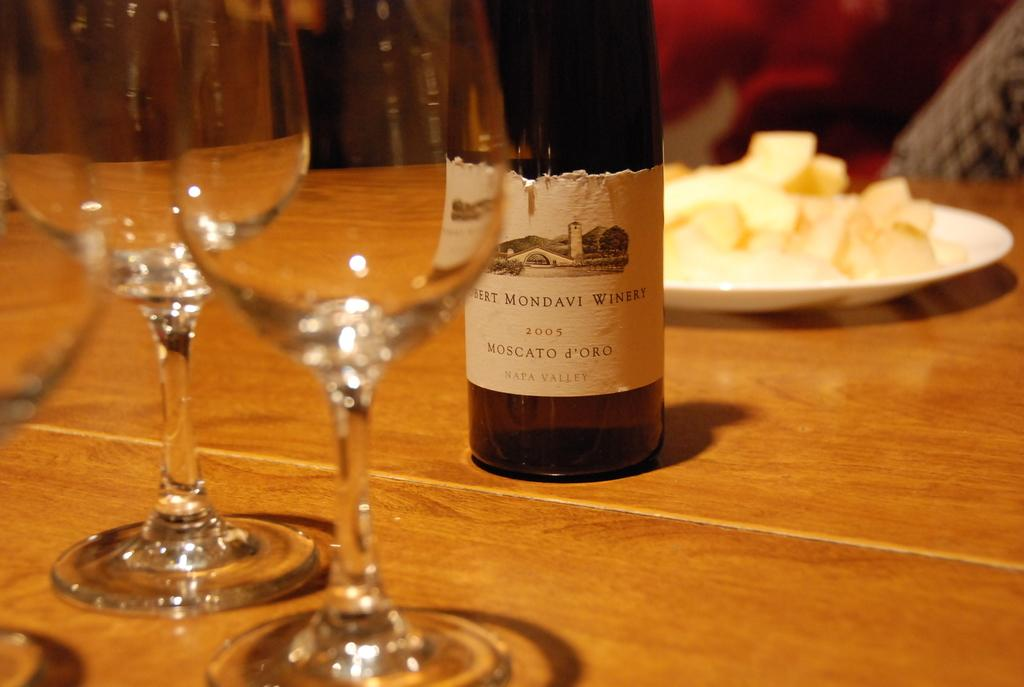What type of tableware can be seen in the image? There are glasses in the image. What else is present on the table in the image? There is a bottle and a plate of food on the table. What might be used for drinking in the image? The glasses in the image can be used for drinking. What is on the plate that is visible in the image? There is a plate of food in the image. What type of science experiment is being conducted on the table in the image? There is no science experiment present in the image; it features glasses, a bottle, and a plate of food on a table. What type of protest is taking place in the image? There is no protest present in the image; it features glasses, a bottle, and a plate of food on a table. 